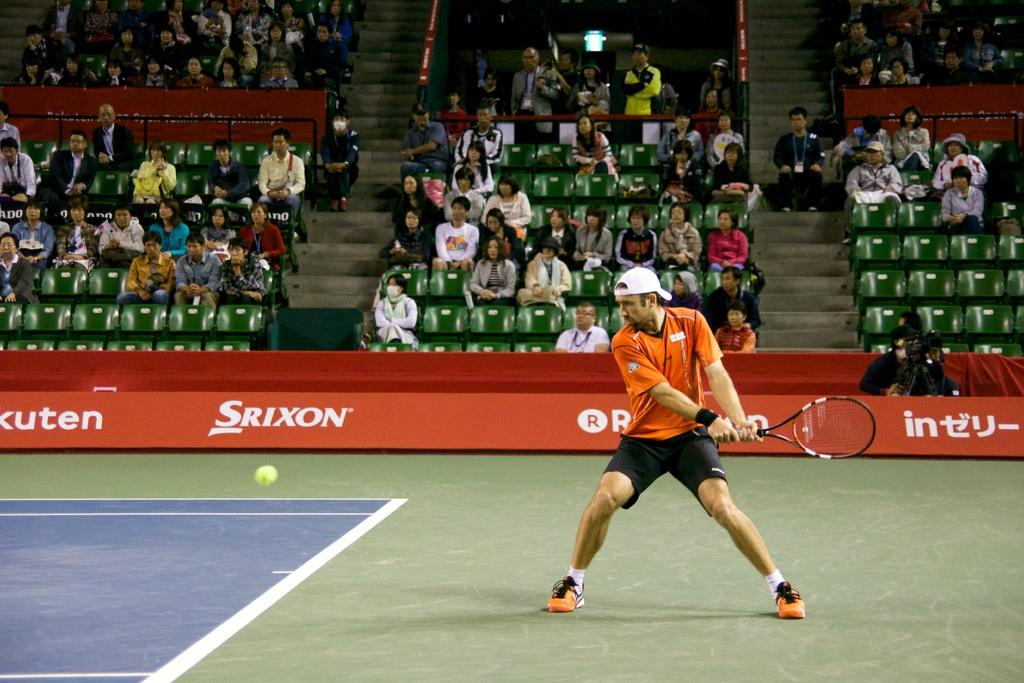<image>
Give a short and clear explanation of the subsequent image. A tennis player returns the ball in front of a SRIXON advertisement. 